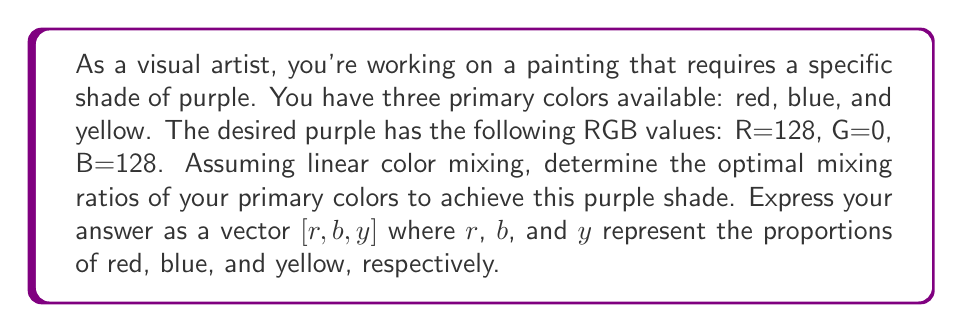Could you help me with this problem? To solve this problem, we'll use linear algebra to set up and solve a system of equations:

1) First, let's define the RGB values of our primary colors:
   Red:   $[255, 0, 0]$
   Blue:  $[0, 0, 255]$
   Yellow: $[255, 255, 0]$

2) We want to find $r$, $b$, and $y$ such that:
   $$r[255, 0, 0] + b[0, 0, 255] + y[255, 255, 0] = [128, 0, 128]$$

3) This gives us a system of linear equations:
   $$255r + 0b + 255y = 128$$
   $$0r + 0b + 255y = 0$$
   $$0r + 255b + 0y = 128$$

4) We can represent this as a matrix equation:
   $$\begin{bmatrix}
   255 & 0 & 255 \\
   0 & 0 & 255 \\
   0 & 255 & 0
   \end{bmatrix}
   \begin{bmatrix}
   r \\ b \\ y
   \end{bmatrix} =
   \begin{bmatrix}
   128 \\ 0 \\ 128
   \end{bmatrix}$$

5) Solving this system (using Gaussian elimination or matrix inversion):
   $$r = \frac{128}{255} = 0.502$$
   $$b = \frac{128}{255} = 0.502$$
   $$y = 0$$

6) To express these as proportions that sum to 1, we normalize:
   $$r = b = \frac{0.502}{0.502 + 0.502 + 0} = 0.5$$
   $$y = 0$$

Therefore, the optimal mixing ratio is $[0.5, 0.5, 0]$.
Answer: $[0.5, 0.5, 0]$ 